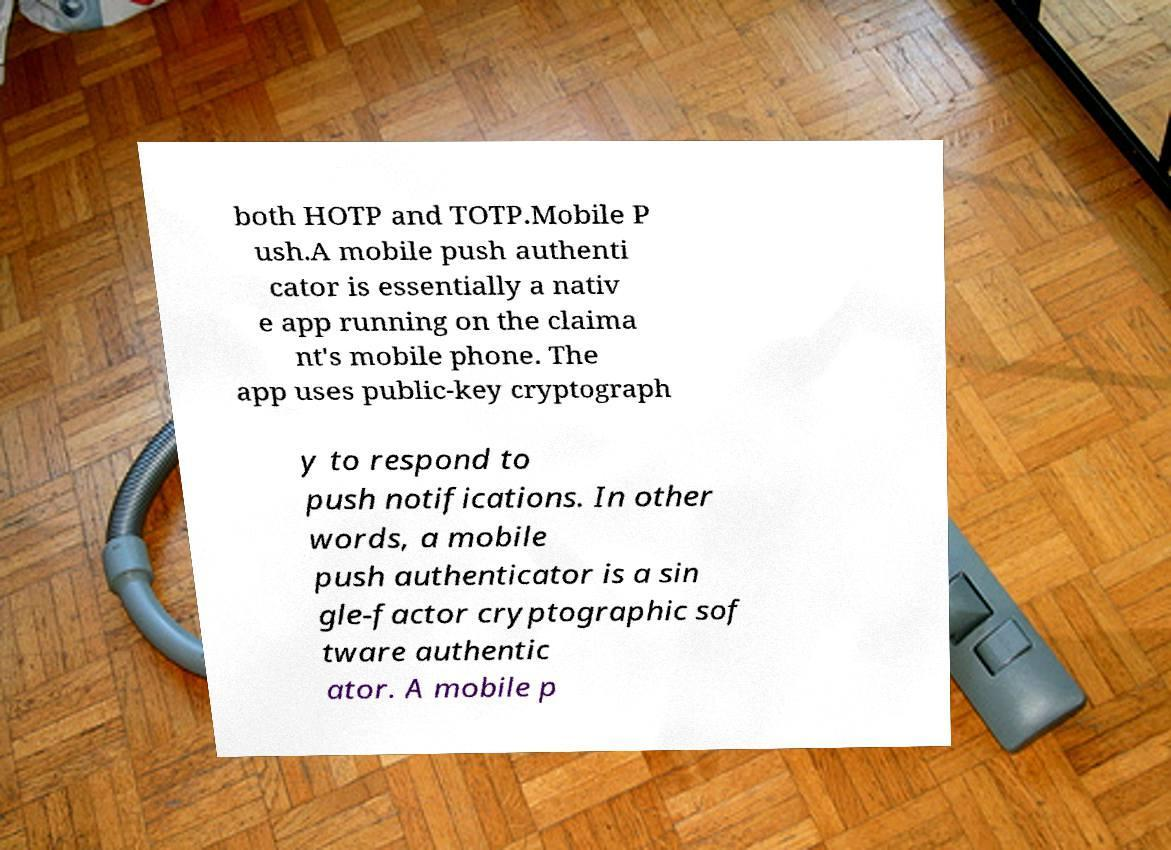There's text embedded in this image that I need extracted. Can you transcribe it verbatim? both HOTP and TOTP.Mobile P ush.A mobile push authenti cator is essentially a nativ e app running on the claima nt's mobile phone. The app uses public-key cryptograph y to respond to push notifications. In other words, a mobile push authenticator is a sin gle-factor cryptographic sof tware authentic ator. A mobile p 